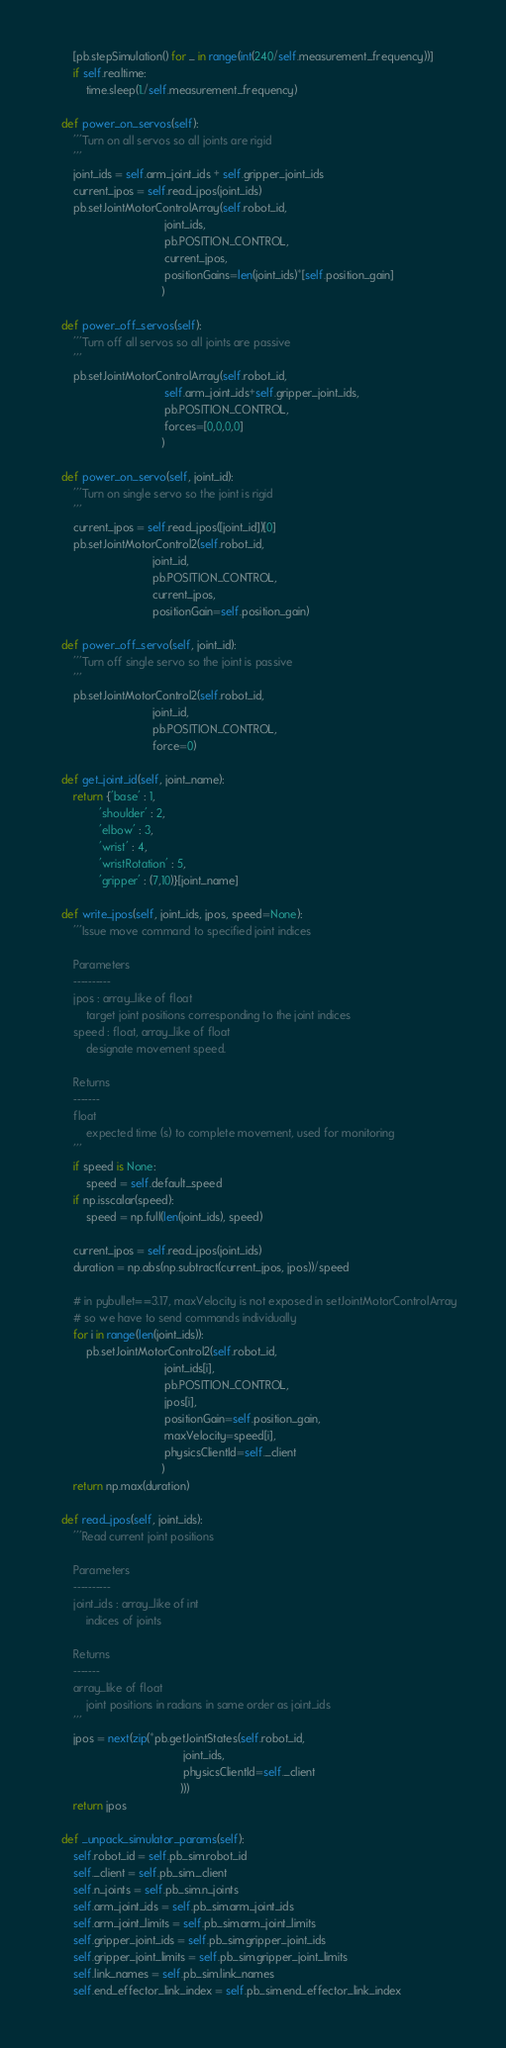Convert code to text. <code><loc_0><loc_0><loc_500><loc_500><_Python_>        [pb.stepSimulation() for _ in range(int(240/self.measurement_frequency))]
        if self.realtime:
            time.sleep(1./self.measurement_frequency)

    def power_on_servos(self):
        '''Turn on all servos so all joints are rigid
        '''
        joint_ids = self.arm_joint_ids + self.gripper_joint_ids
        current_jpos = self.read_jpos(joint_ids)
        pb.setJointMotorControlArray(self.robot_id,
                                     joint_ids,
                                     pb.POSITION_CONTROL,
                                     current_jpos,
                                     positionGains=len(joint_ids)*[self.position_gain]
                                    )

    def power_off_servos(self):
        '''Turn off all servos so all joints are passive
        '''
        pb.setJointMotorControlArray(self.robot_id,
                                     self.arm_joint_ids+self.gripper_joint_ids,
                                     pb.POSITION_CONTROL,
                                     forces=[0,0,0,0]
                                    )

    def power_on_servo(self, joint_id):
        '''Turn on single servo so the joint is rigid
        '''
        current_jpos = self.read_jpos([joint_id])[0]
        pb.setJointMotorControl2(self.robot_id,
                                 joint_id,
                                 pb.POSITION_CONTROL,
                                 current_jpos,
                                 positionGain=self.position_gain)

    def power_off_servo(self, joint_id):
        '''Turn off single servo so the joint is passive
        '''
        pb.setJointMotorControl2(self.robot_id,
                                 joint_id,
                                 pb.POSITION_CONTROL,
                                 force=0)

    def get_joint_id(self, joint_name):
        return {'base' : 1,
                'shoulder' : 2,
                'elbow' : 3,
                'wrist' : 4,
                'wristRotation' : 5,
                'gripper' : (7,10)}[joint_name]

    def write_jpos(self, joint_ids, jpos, speed=None):
        '''Issue move command to specified joint indices

        Parameters
        ----------
        jpos : array_like of float
            target joint positions corresponding to the joint indices
        speed : float, array_like of float
            designate movement speed.

        Returns
        -------
        float
            expected time (s) to complete movement, used for monitoring
        '''
        if speed is None:
            speed = self.default_speed
        if np.isscalar(speed):
            speed = np.full(len(joint_ids), speed)

        current_jpos = self.read_jpos(joint_ids)
        duration = np.abs(np.subtract(current_jpos, jpos))/speed

        # in pybullet==3.17, maxVelocity is not exposed in setJointMotorControlArray
        # so we have to send commands individually
        for i in range(len(joint_ids)):
            pb.setJointMotorControl2(self.robot_id,
                                     joint_ids[i],
                                     pb.POSITION_CONTROL,
                                     jpos[i],
                                     positionGain=self.position_gain,
                                     maxVelocity=speed[i],
                                     physicsClientId=self._client
                                    )
        return np.max(duration)

    def read_jpos(self, joint_ids):
        '''Read current joint positions

        Parameters
        ----------
        joint_ids : array_like of int
            indices of joints

        Returns
        -------
        array_like of float
            joint positions in radians in same order as joint_ids
        '''
        jpos = next(zip(*pb.getJointStates(self.robot_id,
                                           joint_ids,
                                           physicsClientId=self._client
                                          )))
        return jpos

    def _unpack_simulator_params(self):
        self.robot_id = self.pb_sim.robot_id
        self._client = self.pb_sim._client
        self.n_joints = self.pb_sim.n_joints
        self.arm_joint_ids = self.pb_sim.arm_joint_ids
        self.arm_joint_limits = self.pb_sim.arm_joint_limits
        self.gripper_joint_ids = self.pb_sim.gripper_joint_ids
        self.gripper_joint_limits = self.pb_sim.gripper_joint_limits
        self.link_names = self.pb_sim.link_names
        self.end_effector_link_index = self.pb_sim.end_effector_link_index

</code> 